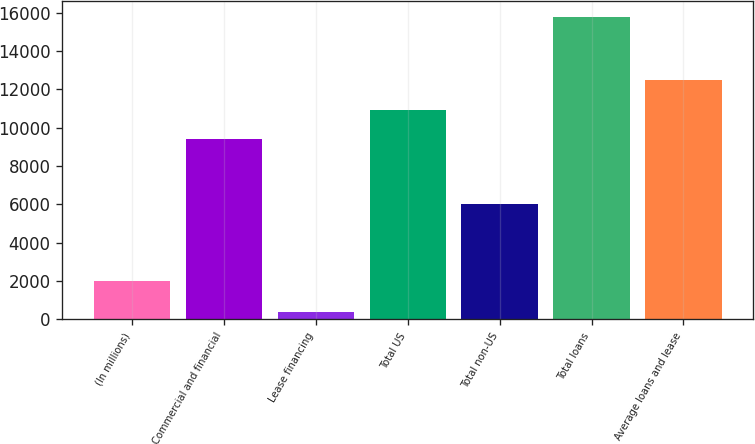<chart> <loc_0><loc_0><loc_500><loc_500><bar_chart><fcel>(In millions)<fcel>Commercial and financial<fcel>Lease financing<fcel>Total US<fcel>Total non-US<fcel>Total loans<fcel>Average loans and lease<nl><fcel>2007<fcel>9402<fcel>396<fcel>10942.6<fcel>6004<fcel>15802<fcel>12483.2<nl></chart> 